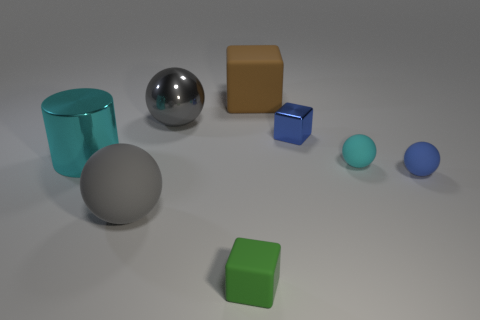Does the shiny sphere have the same color as the big rubber ball?
Provide a short and direct response. Yes. There is another large ball that is the same color as the large matte ball; what material is it?
Make the answer very short. Metal. What size is the matte ball that is the same color as the large metal sphere?
Your answer should be very brief. Large. What is the material of the large brown cube?
Offer a terse response. Rubber. Is the material of the tiny green thing the same as the large gray thing that is behind the blue block?
Give a very brief answer. No. What color is the big matte thing in front of the cyan object to the left of the cyan matte thing?
Your answer should be very brief. Gray. What is the size of the thing that is behind the small metal thing and in front of the large brown block?
Provide a succinct answer. Large. What number of other objects are there of the same shape as the cyan matte object?
Your answer should be very brief. 3. Is the shape of the big brown thing the same as the cyan thing that is to the left of the brown rubber thing?
Your response must be concise. No. What number of brown matte things are right of the big brown object?
Your answer should be very brief. 0. 